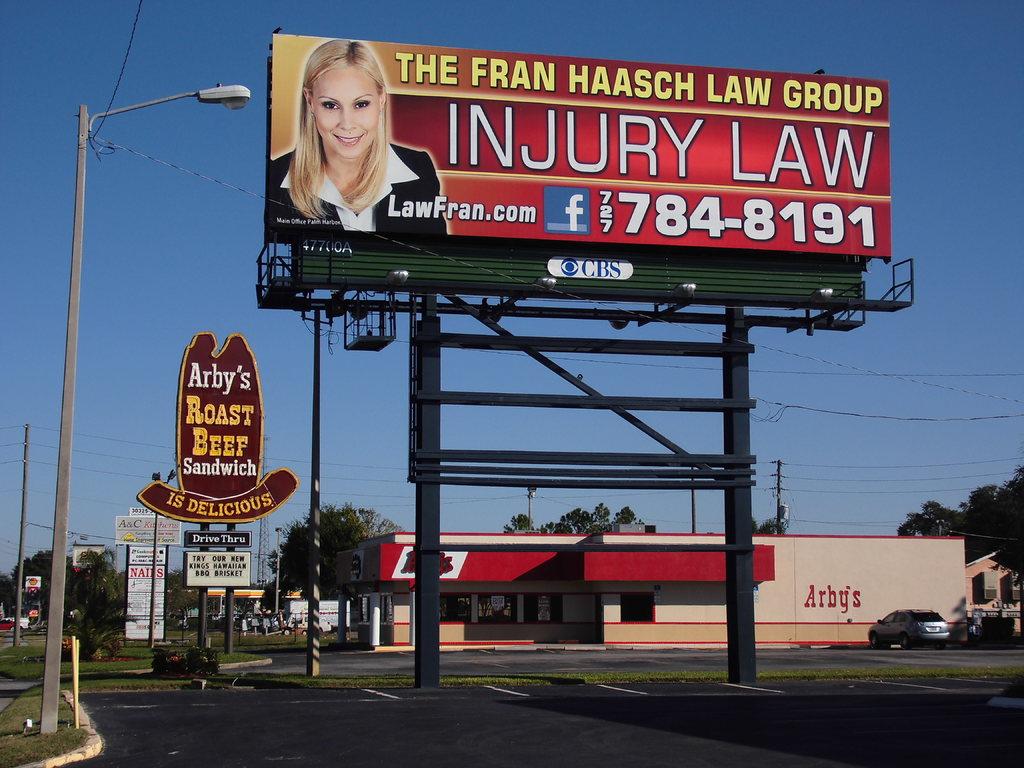What is being advertised?
Provide a short and direct response. The fran haasch law group. What is the phone number?
Provide a succinct answer. 727-784-8191. 